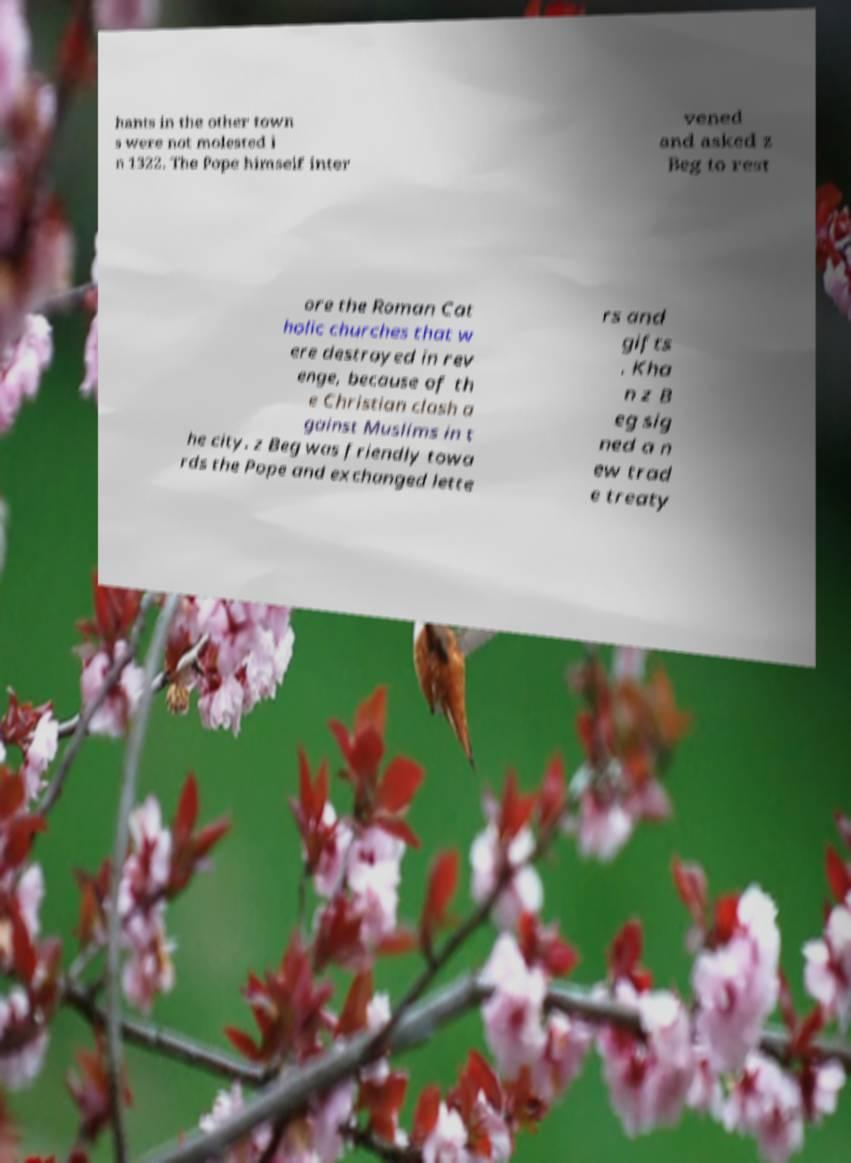For documentation purposes, I need the text within this image transcribed. Could you provide that? hants in the other town s were not molested i n 1322. The Pope himself inter vened and asked z Beg to rest ore the Roman Cat holic churches that w ere destroyed in rev enge, because of th e Christian clash a gainst Muslims in t he city. z Beg was friendly towa rds the Pope and exchanged lette rs and gifts . Kha n z B eg sig ned a n ew trad e treaty 